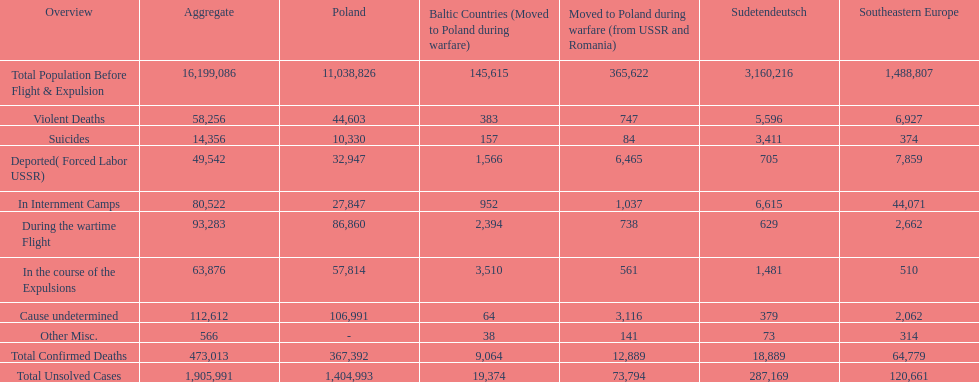What was responsible for causing the majority of mortalities? Cause undetermined. 